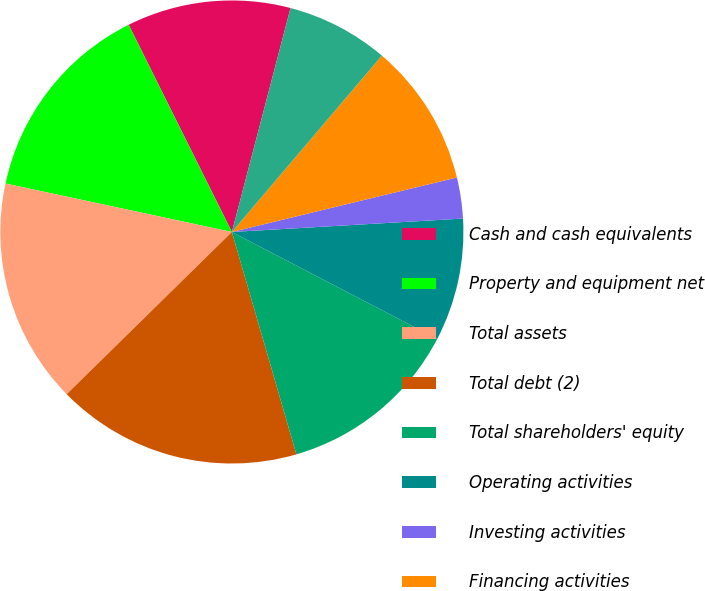Convert chart to OTSL. <chart><loc_0><loc_0><loc_500><loc_500><pie_chart><fcel>Cash and cash equivalents<fcel>Property and equipment net<fcel>Total assets<fcel>Total debt (2)<fcel>Total shareholders' equity<fcel>Operating activities<fcel>Investing activities<fcel>Financing activities<fcel>Towers owned at the beginning<fcel>Towers constructed<nl><fcel>11.43%<fcel>14.29%<fcel>15.71%<fcel>17.14%<fcel>12.86%<fcel>8.57%<fcel>2.86%<fcel>10.0%<fcel>7.14%<fcel>0.0%<nl></chart> 